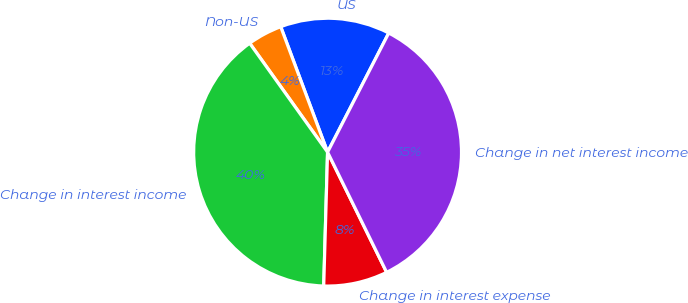<chart> <loc_0><loc_0><loc_500><loc_500><pie_chart><fcel>US<fcel>Non-US<fcel>Change in interest income<fcel>Change in interest expense<fcel>Change in net interest income<nl><fcel>13.24%<fcel>4.19%<fcel>39.66%<fcel>7.73%<fcel>35.18%<nl></chart> 